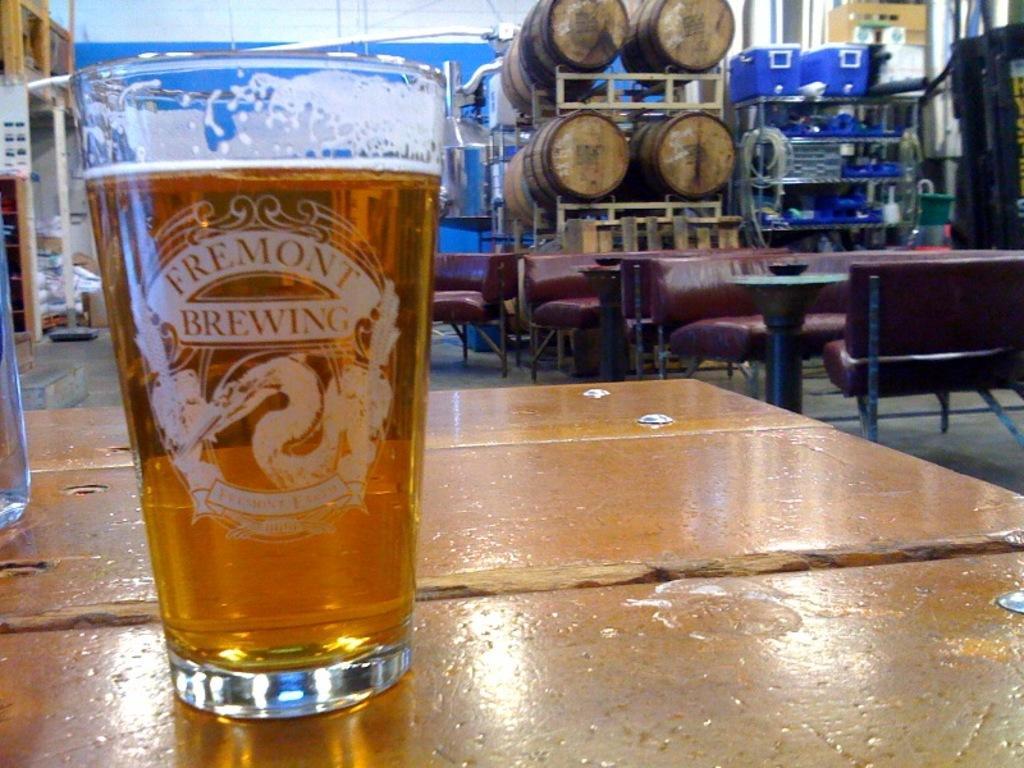Can you describe this image briefly? There is a glass with drink on a platform. Here we can see sofas, tables, and objects. This is floor and there is a rack. 